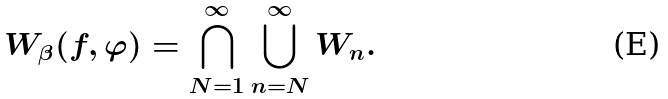Convert formula to latex. <formula><loc_0><loc_0><loc_500><loc_500>W _ { \beta } ( f , \varphi ) = \bigcap _ { N = 1 } ^ { \infty } \bigcup _ { n = N } ^ { \infty } W _ { n } .</formula> 